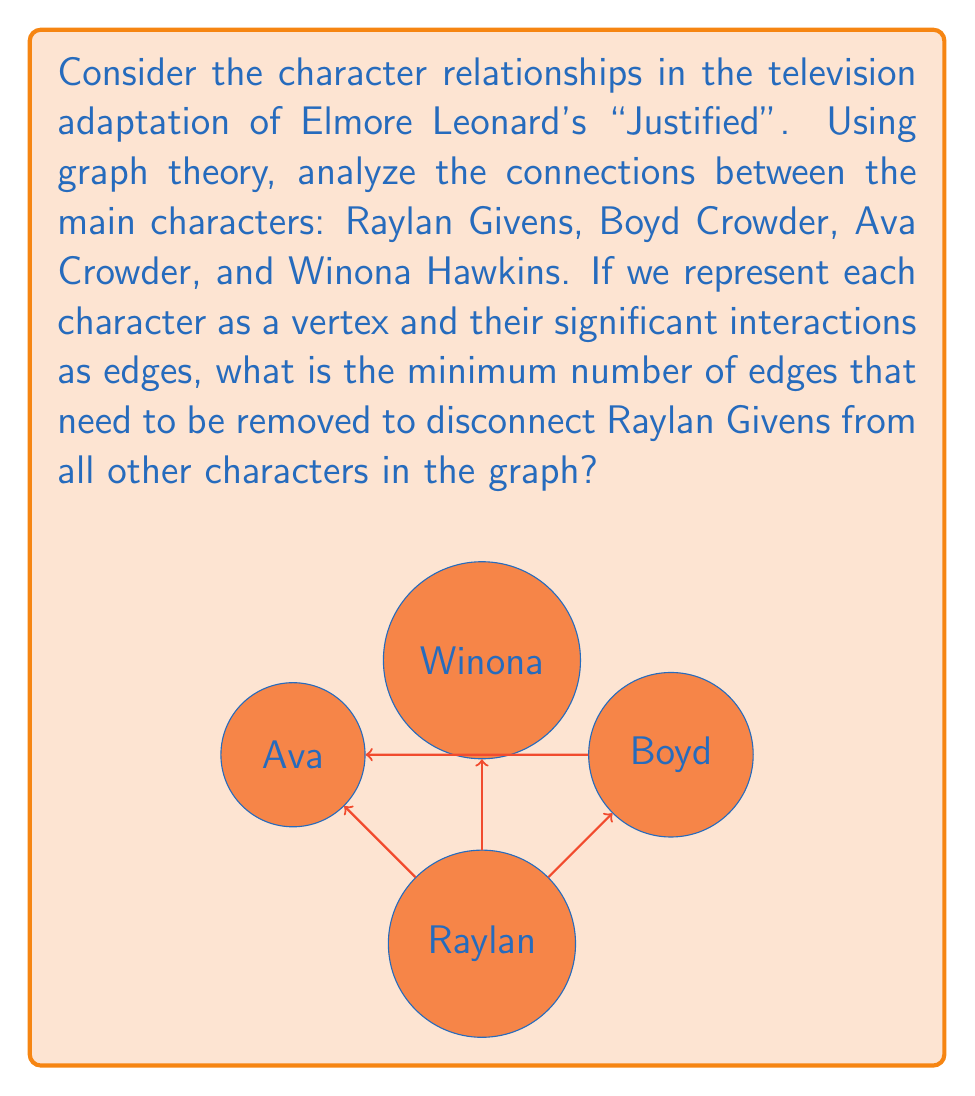Provide a solution to this math problem. To solve this problem, we need to apply the concept of vertex connectivity from graph theory. The vertex connectivity of a graph is the minimum number of vertices that need to be removed to disconnect the graph.

Let's approach this step-by-step:

1) First, we need to understand the graph structure:
   - Raylan Givens is connected to all other characters (Boyd, Ava, and Winona).
   - Boyd and Ava are also connected to each other.
   - Winona is only connected to Raylan.

2) To disconnect Raylan from all other characters, we need to remove all edges incident to Raylan's vertex.

3) Let's count these edges:
   - Edge between Raylan and Boyd
   - Edge between Raylan and Ava
   - Edge between Raylan and Winona

4) In total, there are 3 edges that need to be removed.

5) We can verify this:
   - Removing the edge between Raylan and Winona disconnects Winona.
   - Removing the edge between Raylan and Boyd doesn't fully disconnect Boyd because he's still connected through Ava.
   - Removing the edge between Raylan and Ava completes the disconnection.

6) Therefore, the minimum number of edges that need to be removed to disconnect Raylan from all other characters is 3.

This analysis demonstrates the concept of edge connectivity in graph theory, which is the minimum number of edges that need to be removed to disconnect a graph. In this case, we're focusing on disconnecting a single vertex (Raylan) from the rest of the graph.
Answer: 3 